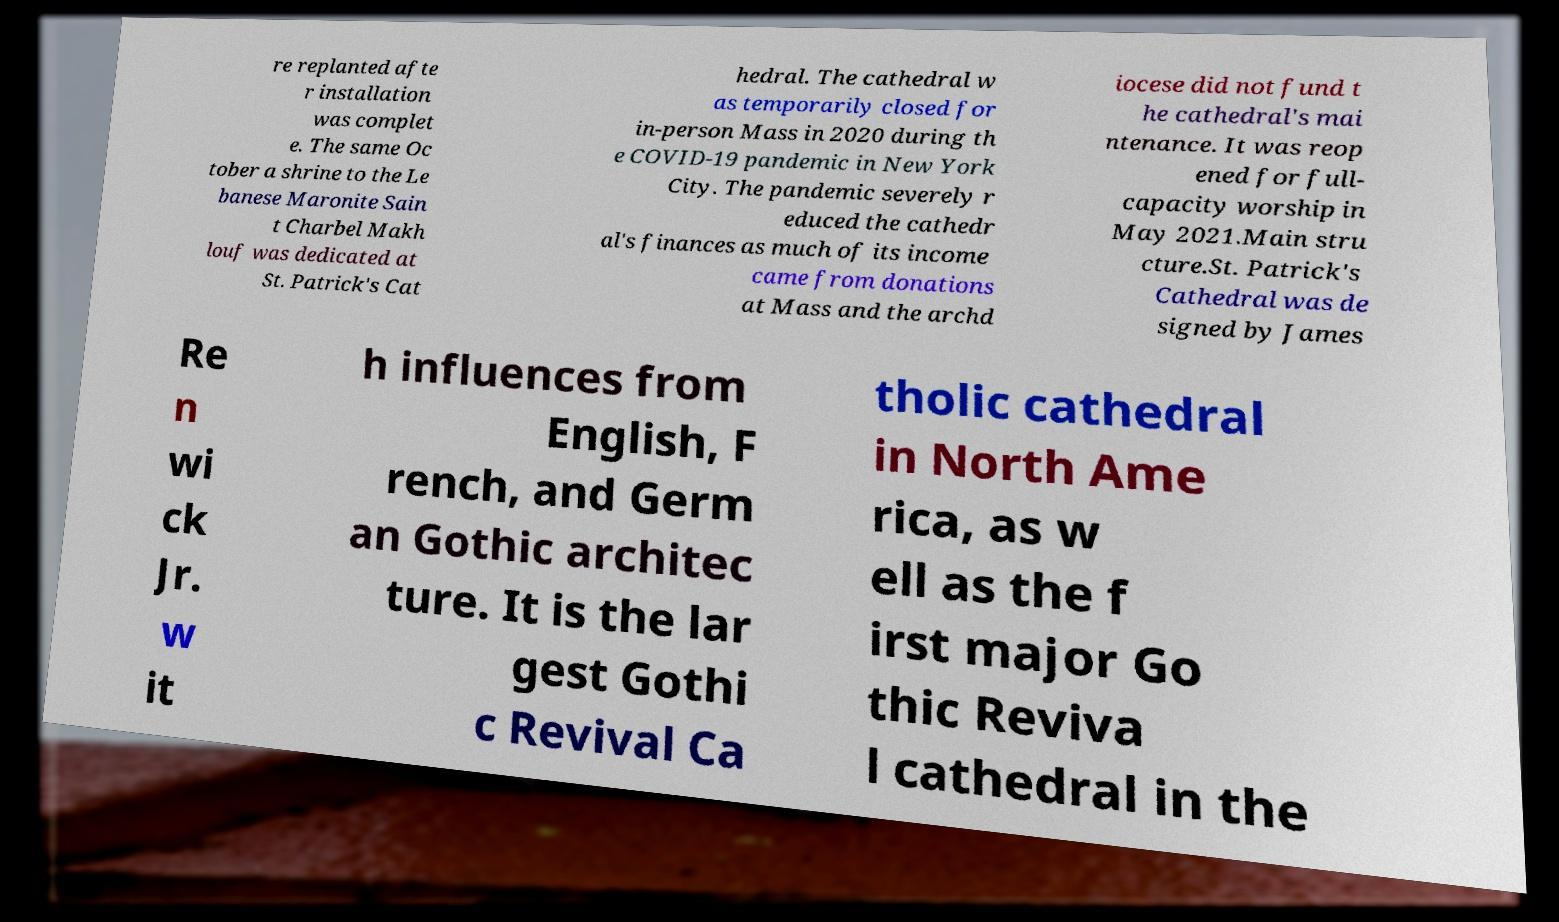I need the written content from this picture converted into text. Can you do that? re replanted afte r installation was complet e. The same Oc tober a shrine to the Le banese Maronite Sain t Charbel Makh louf was dedicated at St. Patrick's Cat hedral. The cathedral w as temporarily closed for in-person Mass in 2020 during th e COVID-19 pandemic in New York City. The pandemic severely r educed the cathedr al's finances as much of its income came from donations at Mass and the archd iocese did not fund t he cathedral's mai ntenance. It was reop ened for full- capacity worship in May 2021.Main stru cture.St. Patrick's Cathedral was de signed by James Re n wi ck Jr. w it h influences from English, F rench, and Germ an Gothic architec ture. It is the lar gest Gothi c Revival Ca tholic cathedral in North Ame rica, as w ell as the f irst major Go thic Reviva l cathedral in the 